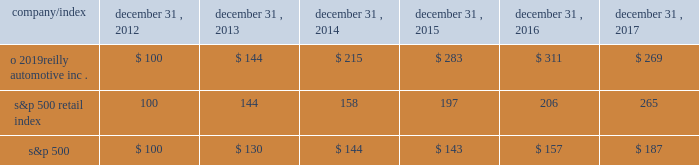Stock performance graph : the graph below shows the cumulative total shareholder return assuming the investment of $ 100 , on december 31 , 2012 , and the reinvestment of dividends thereafter , if any , in the company 2019s common stock versus the standard and poor 2019s s&p 500 retail index ( 201cs&p 500 retail index 201d ) and the standard and poor 2019s s&p 500 index ( 201cs&p 500 201d ) . .

What is the roi of an investment in s&p500 from 2014 to 2016? 
Computations: ((157 - 144) / 144)
Answer: 0.09028. 